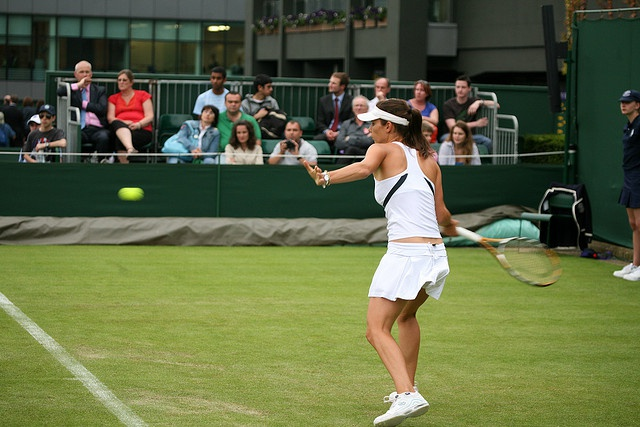Describe the objects in this image and their specific colors. I can see people in black, lavender, tan, and salmon tones, people in black, gray, brown, and lightpink tones, tennis racket in black, olive, and gray tones, people in black, brown, maroon, and lightgray tones, and potted plant in black and gray tones in this image. 